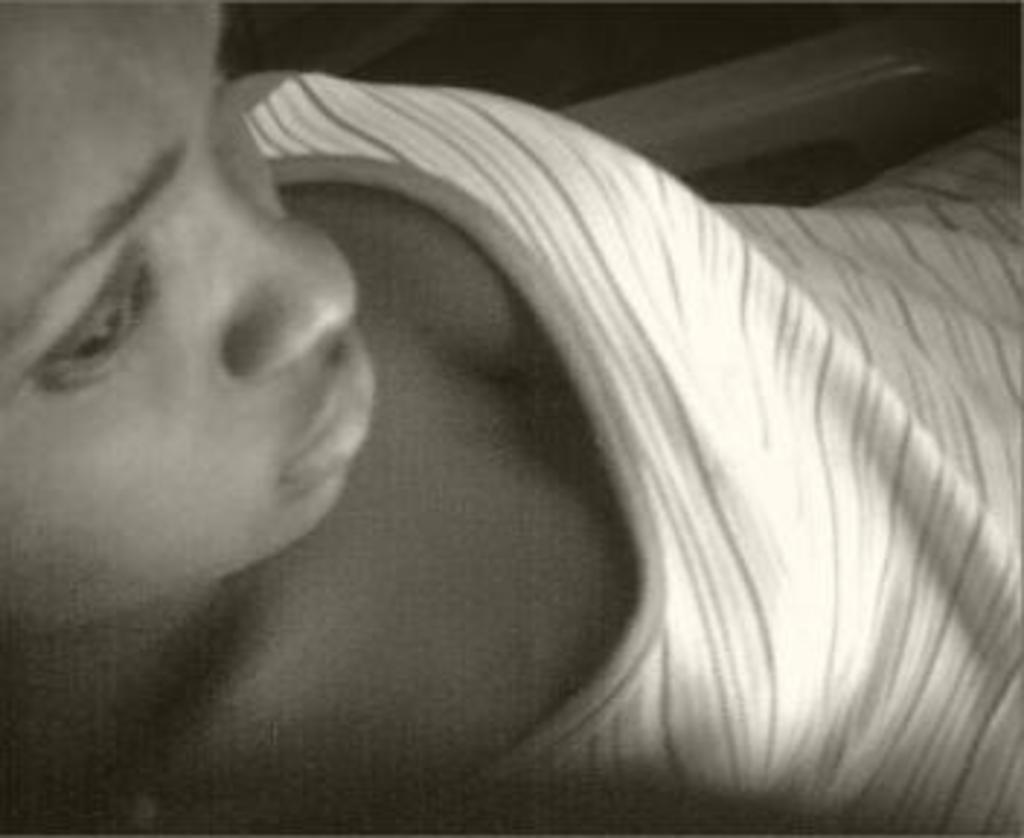In one or two sentences, can you explain what this image depicts? In the picture we can see face of a person. 